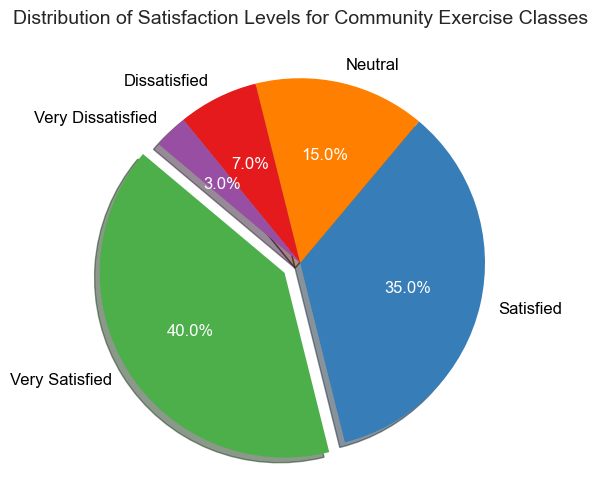What percentage of respondents are either Very Satisfied or Satisfied? Add the percentage of Very Satisfied (40%) and Satisfied (35%) respondents: 40 + 35 = 75
Answer: 75% Which satisfaction level has the smallest percentage of respondents? The "Very Dissatisfied" slice is the smallest, which is labeled 3%.
Answer: Very Dissatisfied How much larger is the Very Satisfied portion compared to the Dissatisfied portion? The Very Satisfied percentage is 40% and the Dissatisfied percentage is 7%. Subtract the latter from the former: 40 - 7 = 33
Answer: 33% What percentage of respondents are not satisfied (i.e., Neutral, Dissatisfied, and Very Dissatisfied)? Add the percentage of Neutral (15%), Dissatisfied (7%), and Very Dissatisfied (3%) respondents: 15 + 7 + 3 = 25
Answer: 25% Is the number of respondents Satisfied larger than Neutral and Dissatisfied combined? The Satisfied percentage is 35%. The combined percentage of Neutral (15%) and Dissatisfied (7%) respondents is 15 + 7 = 22, which is less than 35%.
Answer: Yes What visual attribute distinguishes the Very Satisfied slice from others in the pie chart? The Very Satisfied slice is exploded, making it appear separated from the rest of the pie chart.
Answer: Exploded slice Which slices are adjacent to the largest slice? The largest slice, Very Satisfied, is flanked by "Satisfied" and "Very Dissatisfied" slices.
Answer: Satisfied and Very Dissatisfied What's the difference in percentage between Satisfied and Neutral respondents? Subtract the percentage of Neutral (15%) from Satisfied (35%): 35 - 15 = 20
Answer: 20 Does the sum of Dissatisfied and Very Dissatisfied percentages surpass Neutral? Add the percentage of Dissatisfied (7%) and Very Dissatisfied (3%): 7 + 3 = 10, which is less than Neutral (15%).
Answer: No 